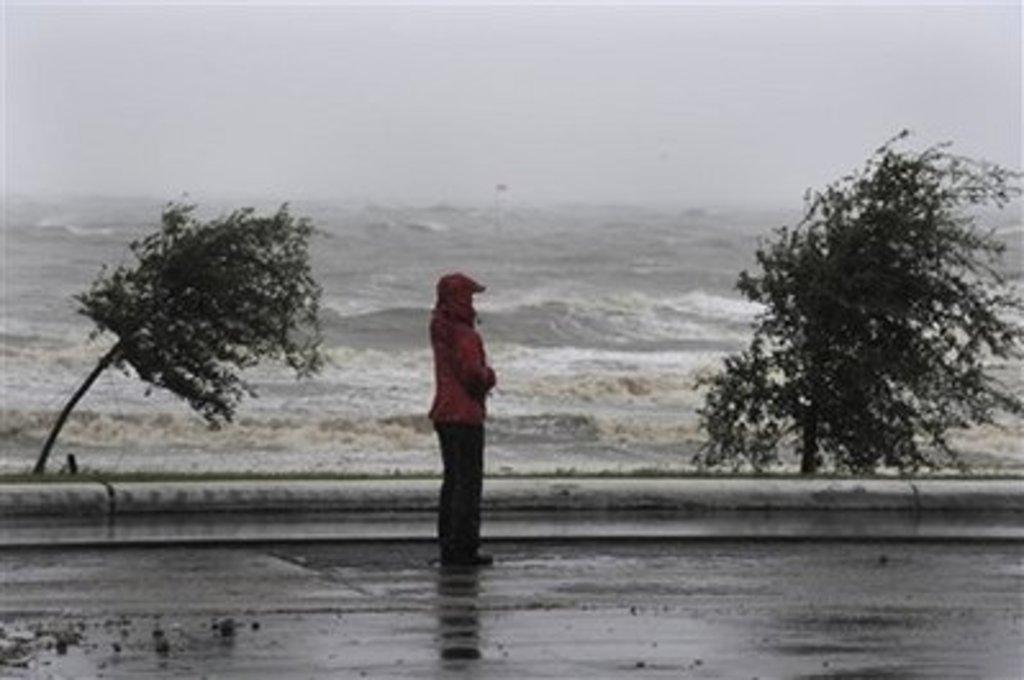What is the person in the image doing? The person is standing on a path in the image. What can be seen in the background of the image? Trees and water are visible in the background of the image. What is the condition of the water in the image? Waves are visible in the water. What type of straw is the person holding in the image? There is no straw present in the image. What kind of jewel can be seen on the person's necklace in the image? There is no necklace or jewel visible in the image. 